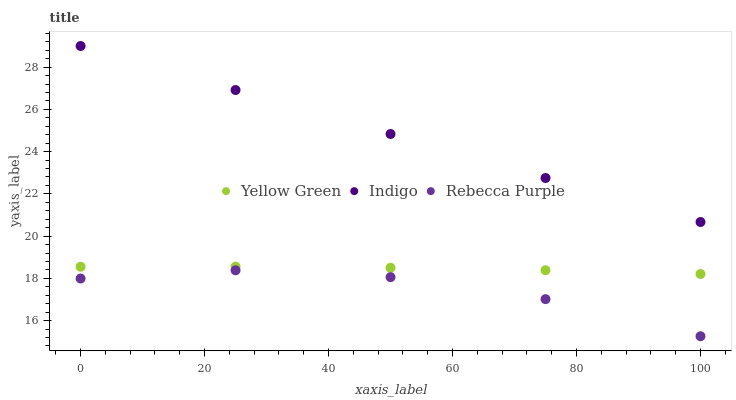Does Rebecca Purple have the minimum area under the curve?
Answer yes or no. Yes. Does Indigo have the maximum area under the curve?
Answer yes or no. Yes. Does Yellow Green have the minimum area under the curve?
Answer yes or no. No. Does Yellow Green have the maximum area under the curve?
Answer yes or no. No. Is Indigo the smoothest?
Answer yes or no. Yes. Is Rebecca Purple the roughest?
Answer yes or no. Yes. Is Yellow Green the smoothest?
Answer yes or no. No. Is Yellow Green the roughest?
Answer yes or no. No. Does Rebecca Purple have the lowest value?
Answer yes or no. Yes. Does Yellow Green have the lowest value?
Answer yes or no. No. Does Indigo have the highest value?
Answer yes or no. Yes. Does Yellow Green have the highest value?
Answer yes or no. No. Is Rebecca Purple less than Yellow Green?
Answer yes or no. Yes. Is Indigo greater than Rebecca Purple?
Answer yes or no. Yes. Does Rebecca Purple intersect Yellow Green?
Answer yes or no. No. 